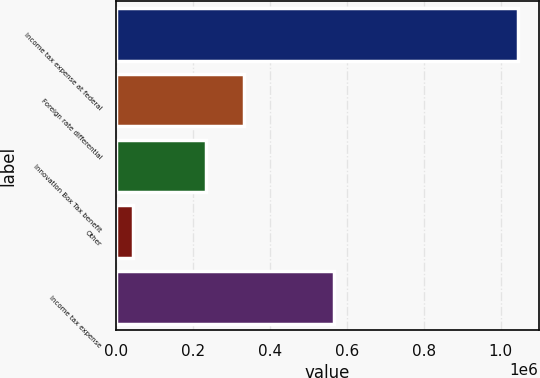Convert chart. <chart><loc_0><loc_0><loc_500><loc_500><bar_chart><fcel>Income tax expense at federal<fcel>Foreign rate differential<fcel>Innovation Box Tax benefit<fcel>Other<fcel>Income tax expense<nl><fcel>1.04631e+06<fcel>333713<fcel>233545<fcel>44625<fcel>567695<nl></chart> 